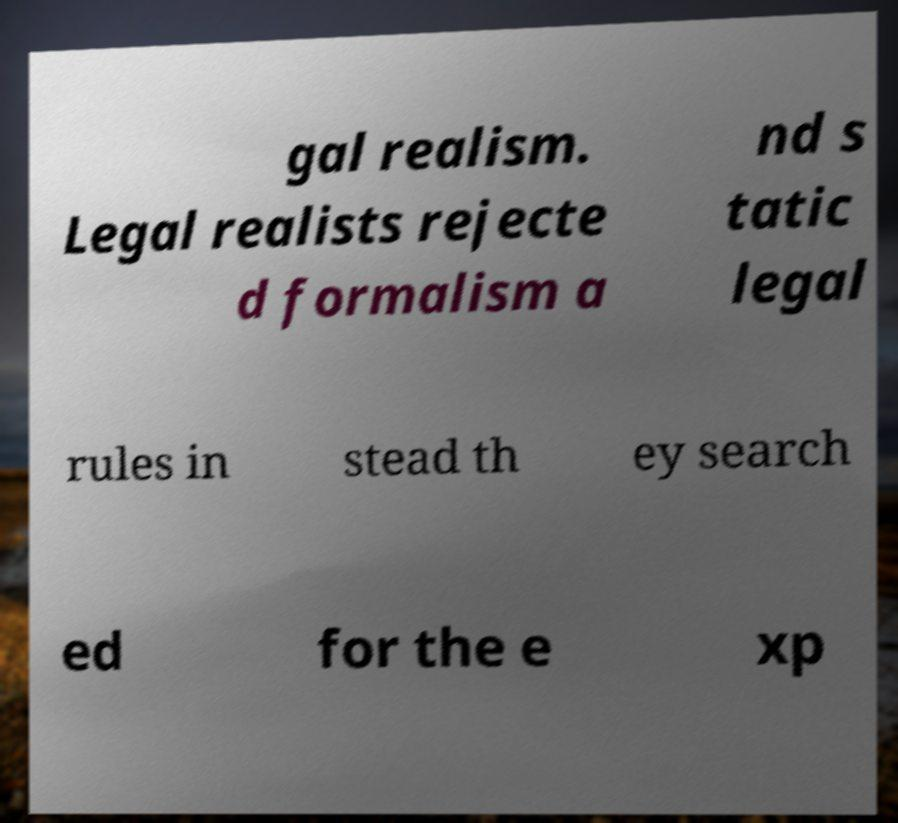Can you read and provide the text displayed in the image?This photo seems to have some interesting text. Can you extract and type it out for me? gal realism. Legal realists rejecte d formalism a nd s tatic legal rules in stead th ey search ed for the e xp 